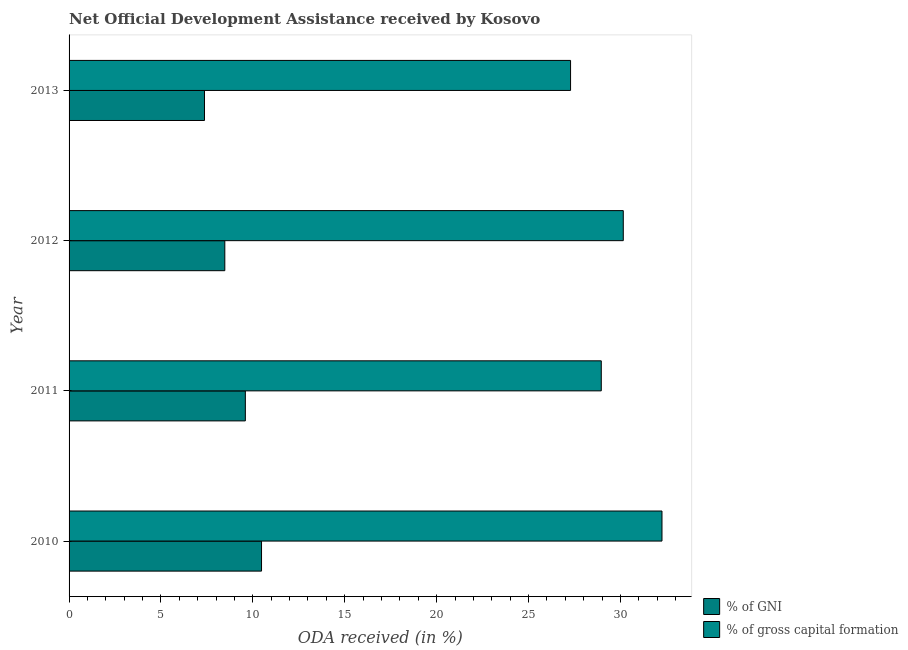How many groups of bars are there?
Your answer should be very brief. 4. Are the number of bars per tick equal to the number of legend labels?
Your answer should be very brief. Yes. How many bars are there on the 1st tick from the bottom?
Provide a succinct answer. 2. What is the oda received as percentage of gross capital formation in 2011?
Your answer should be compact. 28.96. Across all years, what is the maximum oda received as percentage of gni?
Offer a very short reply. 10.47. Across all years, what is the minimum oda received as percentage of gross capital formation?
Keep it short and to the point. 27.29. In which year was the oda received as percentage of gni maximum?
Your answer should be very brief. 2010. In which year was the oda received as percentage of gni minimum?
Give a very brief answer. 2013. What is the total oda received as percentage of gross capital formation in the graph?
Keep it short and to the point. 118.67. What is the difference between the oda received as percentage of gni in 2011 and that in 2012?
Make the answer very short. 1.12. What is the difference between the oda received as percentage of gross capital formation in 2011 and the oda received as percentage of gni in 2013?
Offer a terse response. 21.59. What is the average oda received as percentage of gni per year?
Your response must be concise. 8.98. In the year 2011, what is the difference between the oda received as percentage of gni and oda received as percentage of gross capital formation?
Offer a very short reply. -19.37. In how many years, is the oda received as percentage of gross capital formation greater than 14 %?
Keep it short and to the point. 4. What is the ratio of the oda received as percentage of gross capital formation in 2011 to that in 2013?
Your answer should be very brief. 1.06. What is the difference between the highest and the second highest oda received as percentage of gross capital formation?
Your answer should be very brief. 2.11. In how many years, is the oda received as percentage of gross capital formation greater than the average oda received as percentage of gross capital formation taken over all years?
Provide a succinct answer. 2. What does the 2nd bar from the top in 2013 represents?
Provide a short and direct response. % of GNI. What does the 1st bar from the bottom in 2011 represents?
Your answer should be compact. % of GNI. How many bars are there?
Your answer should be very brief. 8. Are all the bars in the graph horizontal?
Make the answer very short. Yes. Are the values on the major ticks of X-axis written in scientific E-notation?
Offer a very short reply. No. Does the graph contain grids?
Offer a terse response. No. Where does the legend appear in the graph?
Offer a terse response. Bottom right. How many legend labels are there?
Provide a succinct answer. 2. How are the legend labels stacked?
Offer a terse response. Vertical. What is the title of the graph?
Your response must be concise. Net Official Development Assistance received by Kosovo. Does "Import" appear as one of the legend labels in the graph?
Your answer should be compact. No. What is the label or title of the X-axis?
Your answer should be very brief. ODA received (in %). What is the label or title of the Y-axis?
Offer a terse response. Year. What is the ODA received (in %) in % of GNI in 2010?
Provide a succinct answer. 10.47. What is the ODA received (in %) in % of gross capital formation in 2010?
Give a very brief answer. 32.26. What is the ODA received (in %) of % of GNI in 2011?
Your response must be concise. 9.59. What is the ODA received (in %) in % of gross capital formation in 2011?
Keep it short and to the point. 28.96. What is the ODA received (in %) in % of GNI in 2012?
Your answer should be compact. 8.47. What is the ODA received (in %) of % of gross capital formation in 2012?
Your response must be concise. 30.16. What is the ODA received (in %) of % of GNI in 2013?
Give a very brief answer. 7.37. What is the ODA received (in %) in % of gross capital formation in 2013?
Provide a succinct answer. 27.29. Across all years, what is the maximum ODA received (in %) of % of GNI?
Your response must be concise. 10.47. Across all years, what is the maximum ODA received (in %) of % of gross capital formation?
Keep it short and to the point. 32.26. Across all years, what is the minimum ODA received (in %) in % of GNI?
Ensure brevity in your answer.  7.37. Across all years, what is the minimum ODA received (in %) of % of gross capital formation?
Keep it short and to the point. 27.29. What is the total ODA received (in %) of % of GNI in the graph?
Ensure brevity in your answer.  35.91. What is the total ODA received (in %) in % of gross capital formation in the graph?
Make the answer very short. 118.67. What is the difference between the ODA received (in %) in % of GNI in 2010 and that in 2011?
Your answer should be very brief. 0.88. What is the difference between the ODA received (in %) in % of gross capital formation in 2010 and that in 2011?
Ensure brevity in your answer.  3.3. What is the difference between the ODA received (in %) in % of GNI in 2010 and that in 2012?
Your response must be concise. 2. What is the difference between the ODA received (in %) of % of gross capital formation in 2010 and that in 2012?
Make the answer very short. 2.11. What is the difference between the ODA received (in %) in % of GNI in 2010 and that in 2013?
Your answer should be very brief. 3.1. What is the difference between the ODA received (in %) of % of gross capital formation in 2010 and that in 2013?
Provide a succinct answer. 4.97. What is the difference between the ODA received (in %) in % of GNI in 2011 and that in 2012?
Make the answer very short. 1.12. What is the difference between the ODA received (in %) of % of gross capital formation in 2011 and that in 2012?
Your answer should be very brief. -1.2. What is the difference between the ODA received (in %) of % of GNI in 2011 and that in 2013?
Make the answer very short. 2.22. What is the difference between the ODA received (in %) of % of gross capital formation in 2011 and that in 2013?
Keep it short and to the point. 1.67. What is the difference between the ODA received (in %) in % of GNI in 2012 and that in 2013?
Ensure brevity in your answer.  1.11. What is the difference between the ODA received (in %) in % of gross capital formation in 2012 and that in 2013?
Your answer should be very brief. 2.87. What is the difference between the ODA received (in %) of % of GNI in 2010 and the ODA received (in %) of % of gross capital formation in 2011?
Provide a short and direct response. -18.49. What is the difference between the ODA received (in %) of % of GNI in 2010 and the ODA received (in %) of % of gross capital formation in 2012?
Your answer should be very brief. -19.68. What is the difference between the ODA received (in %) of % of GNI in 2010 and the ODA received (in %) of % of gross capital formation in 2013?
Ensure brevity in your answer.  -16.82. What is the difference between the ODA received (in %) of % of GNI in 2011 and the ODA received (in %) of % of gross capital formation in 2012?
Offer a terse response. -20.56. What is the difference between the ODA received (in %) in % of GNI in 2011 and the ODA received (in %) in % of gross capital formation in 2013?
Offer a very short reply. -17.7. What is the difference between the ODA received (in %) in % of GNI in 2012 and the ODA received (in %) in % of gross capital formation in 2013?
Provide a short and direct response. -18.81. What is the average ODA received (in %) of % of GNI per year?
Your answer should be very brief. 8.98. What is the average ODA received (in %) in % of gross capital formation per year?
Your response must be concise. 29.67. In the year 2010, what is the difference between the ODA received (in %) of % of GNI and ODA received (in %) of % of gross capital formation?
Make the answer very short. -21.79. In the year 2011, what is the difference between the ODA received (in %) in % of GNI and ODA received (in %) in % of gross capital formation?
Your answer should be compact. -19.37. In the year 2012, what is the difference between the ODA received (in %) in % of GNI and ODA received (in %) in % of gross capital formation?
Provide a short and direct response. -21.68. In the year 2013, what is the difference between the ODA received (in %) in % of GNI and ODA received (in %) in % of gross capital formation?
Make the answer very short. -19.92. What is the ratio of the ODA received (in %) of % of GNI in 2010 to that in 2011?
Your answer should be compact. 1.09. What is the ratio of the ODA received (in %) in % of gross capital formation in 2010 to that in 2011?
Give a very brief answer. 1.11. What is the ratio of the ODA received (in %) of % of GNI in 2010 to that in 2012?
Provide a succinct answer. 1.24. What is the ratio of the ODA received (in %) in % of gross capital formation in 2010 to that in 2012?
Offer a very short reply. 1.07. What is the ratio of the ODA received (in %) in % of GNI in 2010 to that in 2013?
Your answer should be very brief. 1.42. What is the ratio of the ODA received (in %) of % of gross capital formation in 2010 to that in 2013?
Ensure brevity in your answer.  1.18. What is the ratio of the ODA received (in %) in % of GNI in 2011 to that in 2012?
Your response must be concise. 1.13. What is the ratio of the ODA received (in %) in % of gross capital formation in 2011 to that in 2012?
Offer a terse response. 0.96. What is the ratio of the ODA received (in %) of % of GNI in 2011 to that in 2013?
Your answer should be very brief. 1.3. What is the ratio of the ODA received (in %) of % of gross capital formation in 2011 to that in 2013?
Make the answer very short. 1.06. What is the ratio of the ODA received (in %) in % of GNI in 2012 to that in 2013?
Your answer should be very brief. 1.15. What is the ratio of the ODA received (in %) in % of gross capital formation in 2012 to that in 2013?
Keep it short and to the point. 1.11. What is the difference between the highest and the second highest ODA received (in %) in % of GNI?
Make the answer very short. 0.88. What is the difference between the highest and the second highest ODA received (in %) in % of gross capital formation?
Your answer should be very brief. 2.11. What is the difference between the highest and the lowest ODA received (in %) of % of GNI?
Ensure brevity in your answer.  3.1. What is the difference between the highest and the lowest ODA received (in %) in % of gross capital formation?
Your answer should be compact. 4.97. 